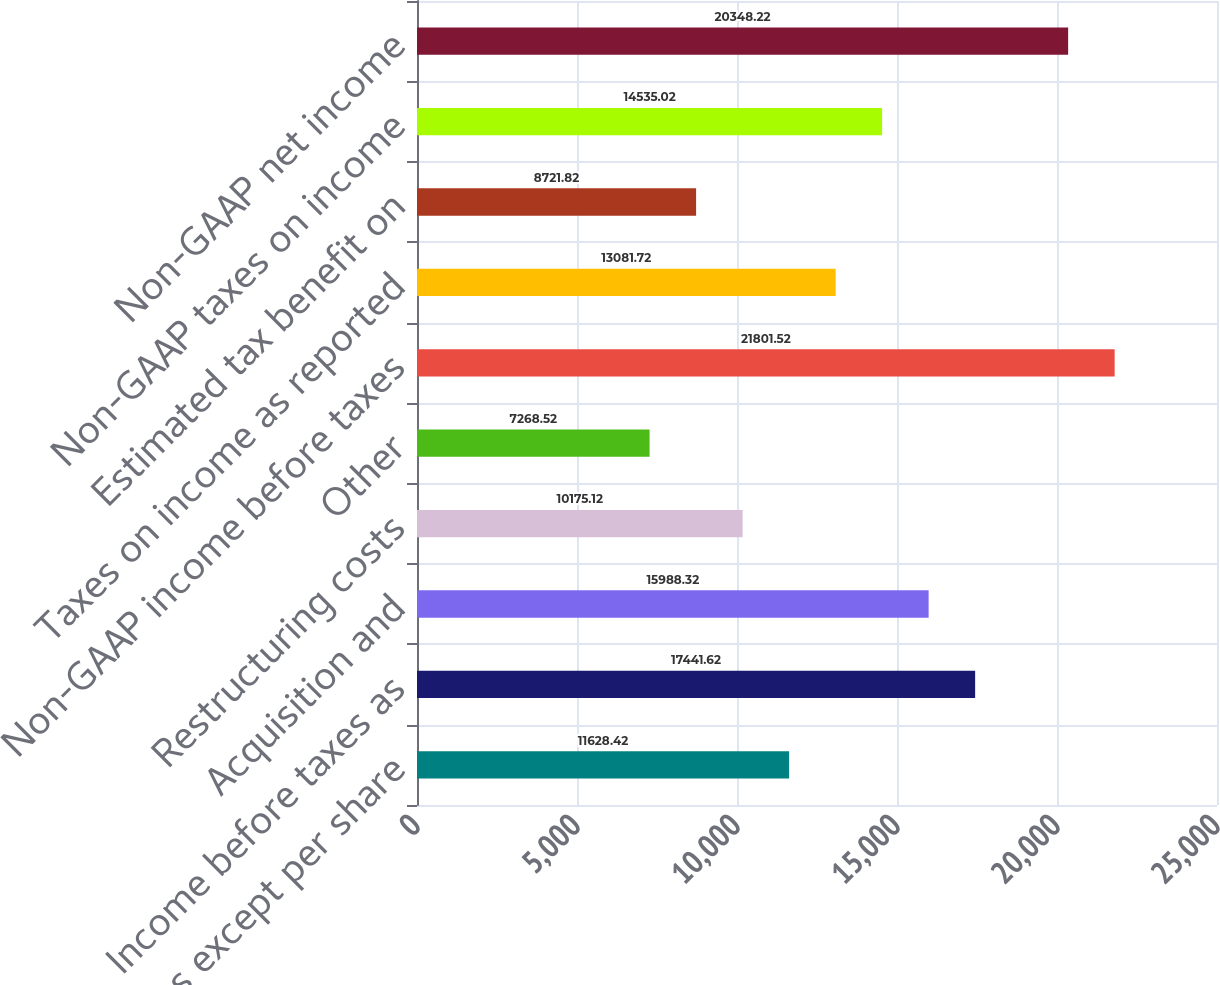Convert chart. <chart><loc_0><loc_0><loc_500><loc_500><bar_chart><fcel>( in millions except per share<fcel>Income before taxes as<fcel>Acquisition and<fcel>Restructuring costs<fcel>Other<fcel>Non-GAAP income before taxes<fcel>Taxes on income as reported<fcel>Estimated tax benefit on<fcel>Non-GAAP taxes on income<fcel>Non-GAAP net income<nl><fcel>11628.4<fcel>17441.6<fcel>15988.3<fcel>10175.1<fcel>7268.52<fcel>21801.5<fcel>13081.7<fcel>8721.82<fcel>14535<fcel>20348.2<nl></chart> 